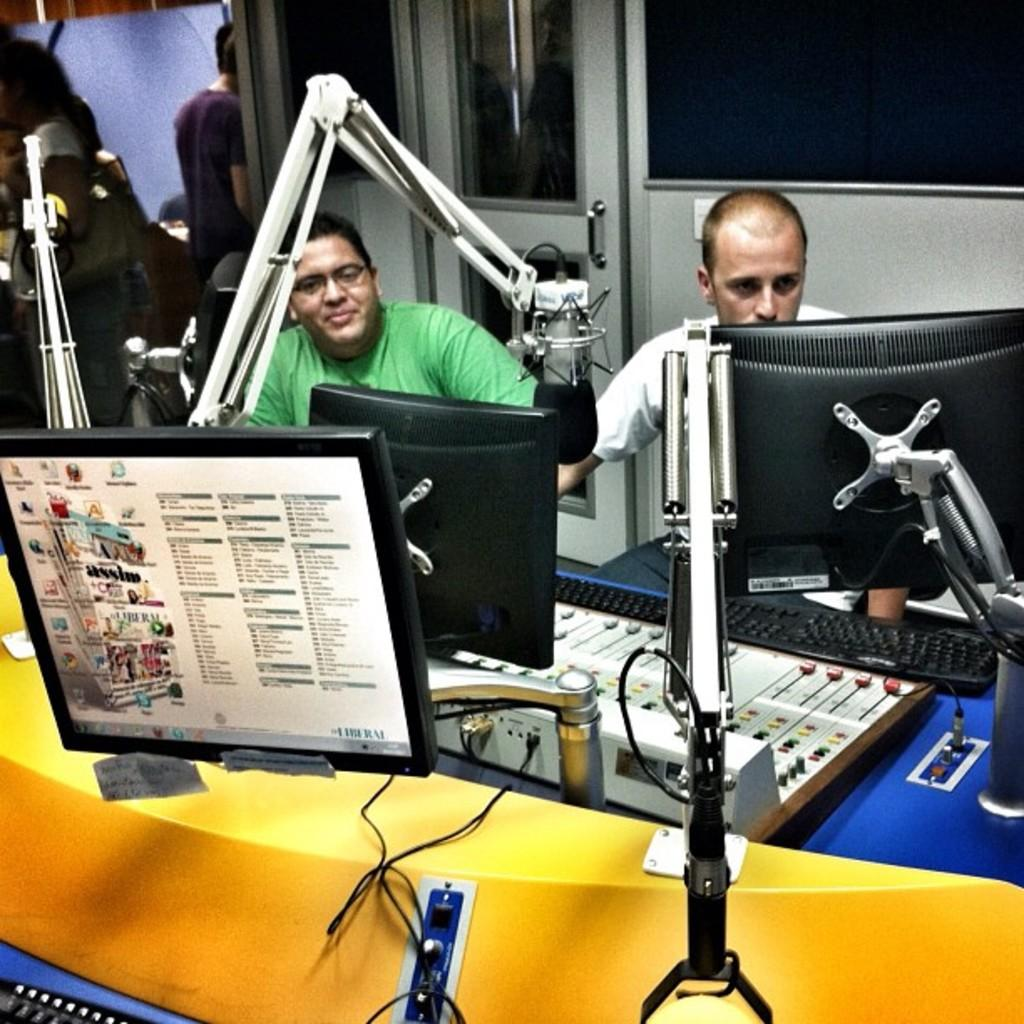What is the main object in the center of the image? There is a table in the center of the image. What is placed on the table? Monitor screens and a keyboard are present on the table. How many people are in the image? There are two people sitting in the image. What can be seen in the background of the image? There is a door visible in the background of the image. What type of fang can be seen in the image? There is no fang present in the image. What kind of blade is being used by one of the people in the image? There is no blade visible in the image; the people are sitting near a table with monitor screens and a keyboard. 